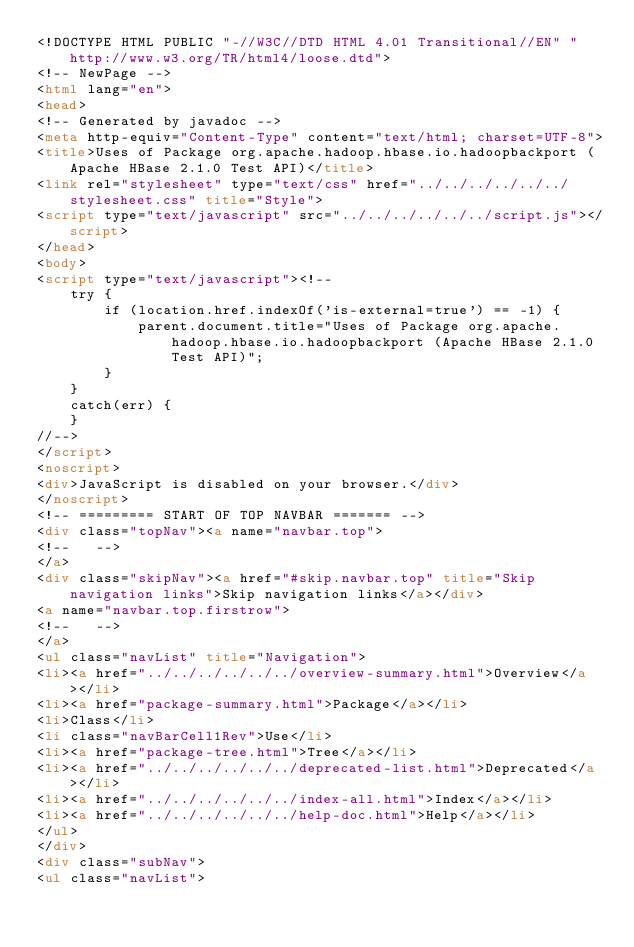<code> <loc_0><loc_0><loc_500><loc_500><_HTML_><!DOCTYPE HTML PUBLIC "-//W3C//DTD HTML 4.01 Transitional//EN" "http://www.w3.org/TR/html4/loose.dtd">
<!-- NewPage -->
<html lang="en">
<head>
<!-- Generated by javadoc -->
<meta http-equiv="Content-Type" content="text/html; charset=UTF-8">
<title>Uses of Package org.apache.hadoop.hbase.io.hadoopbackport (Apache HBase 2.1.0 Test API)</title>
<link rel="stylesheet" type="text/css" href="../../../../../../stylesheet.css" title="Style">
<script type="text/javascript" src="../../../../../../script.js"></script>
</head>
<body>
<script type="text/javascript"><!--
    try {
        if (location.href.indexOf('is-external=true') == -1) {
            parent.document.title="Uses of Package org.apache.hadoop.hbase.io.hadoopbackport (Apache HBase 2.1.0 Test API)";
        }
    }
    catch(err) {
    }
//-->
</script>
<noscript>
<div>JavaScript is disabled on your browser.</div>
</noscript>
<!-- ========= START OF TOP NAVBAR ======= -->
<div class="topNav"><a name="navbar.top">
<!--   -->
</a>
<div class="skipNav"><a href="#skip.navbar.top" title="Skip navigation links">Skip navigation links</a></div>
<a name="navbar.top.firstrow">
<!--   -->
</a>
<ul class="navList" title="Navigation">
<li><a href="../../../../../../overview-summary.html">Overview</a></li>
<li><a href="package-summary.html">Package</a></li>
<li>Class</li>
<li class="navBarCell1Rev">Use</li>
<li><a href="package-tree.html">Tree</a></li>
<li><a href="../../../../../../deprecated-list.html">Deprecated</a></li>
<li><a href="../../../../../../index-all.html">Index</a></li>
<li><a href="../../../../../../help-doc.html">Help</a></li>
</ul>
</div>
<div class="subNav">
<ul class="navList"></code> 